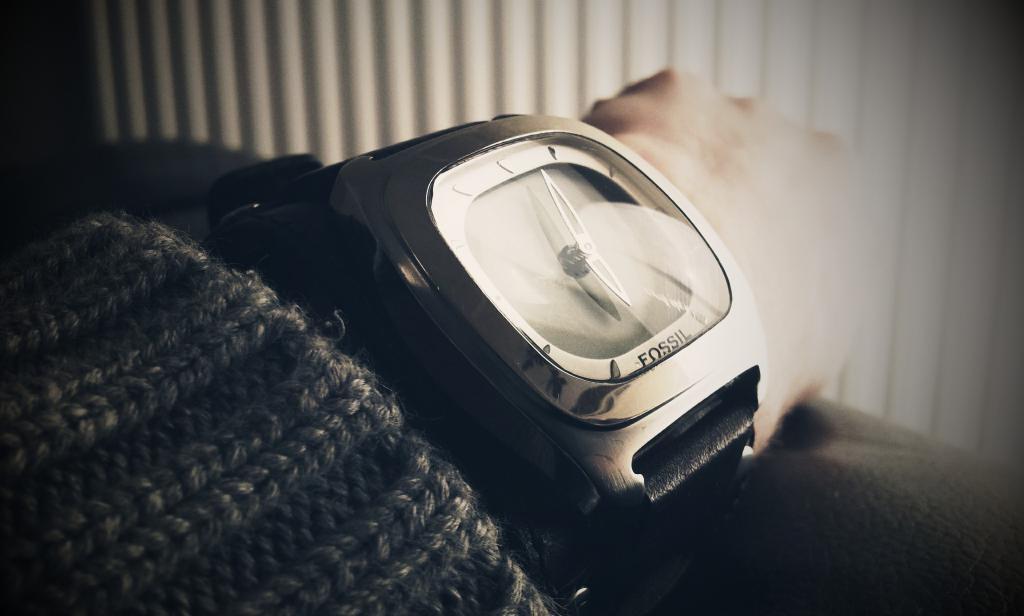What brand is the watch?
Keep it short and to the point. Fossil. What is the time displayed on the watch?
Ensure brevity in your answer.  6:03. 